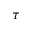Convert formula to latex. <formula><loc_0><loc_0><loc_500><loc_500>\tau</formula> 